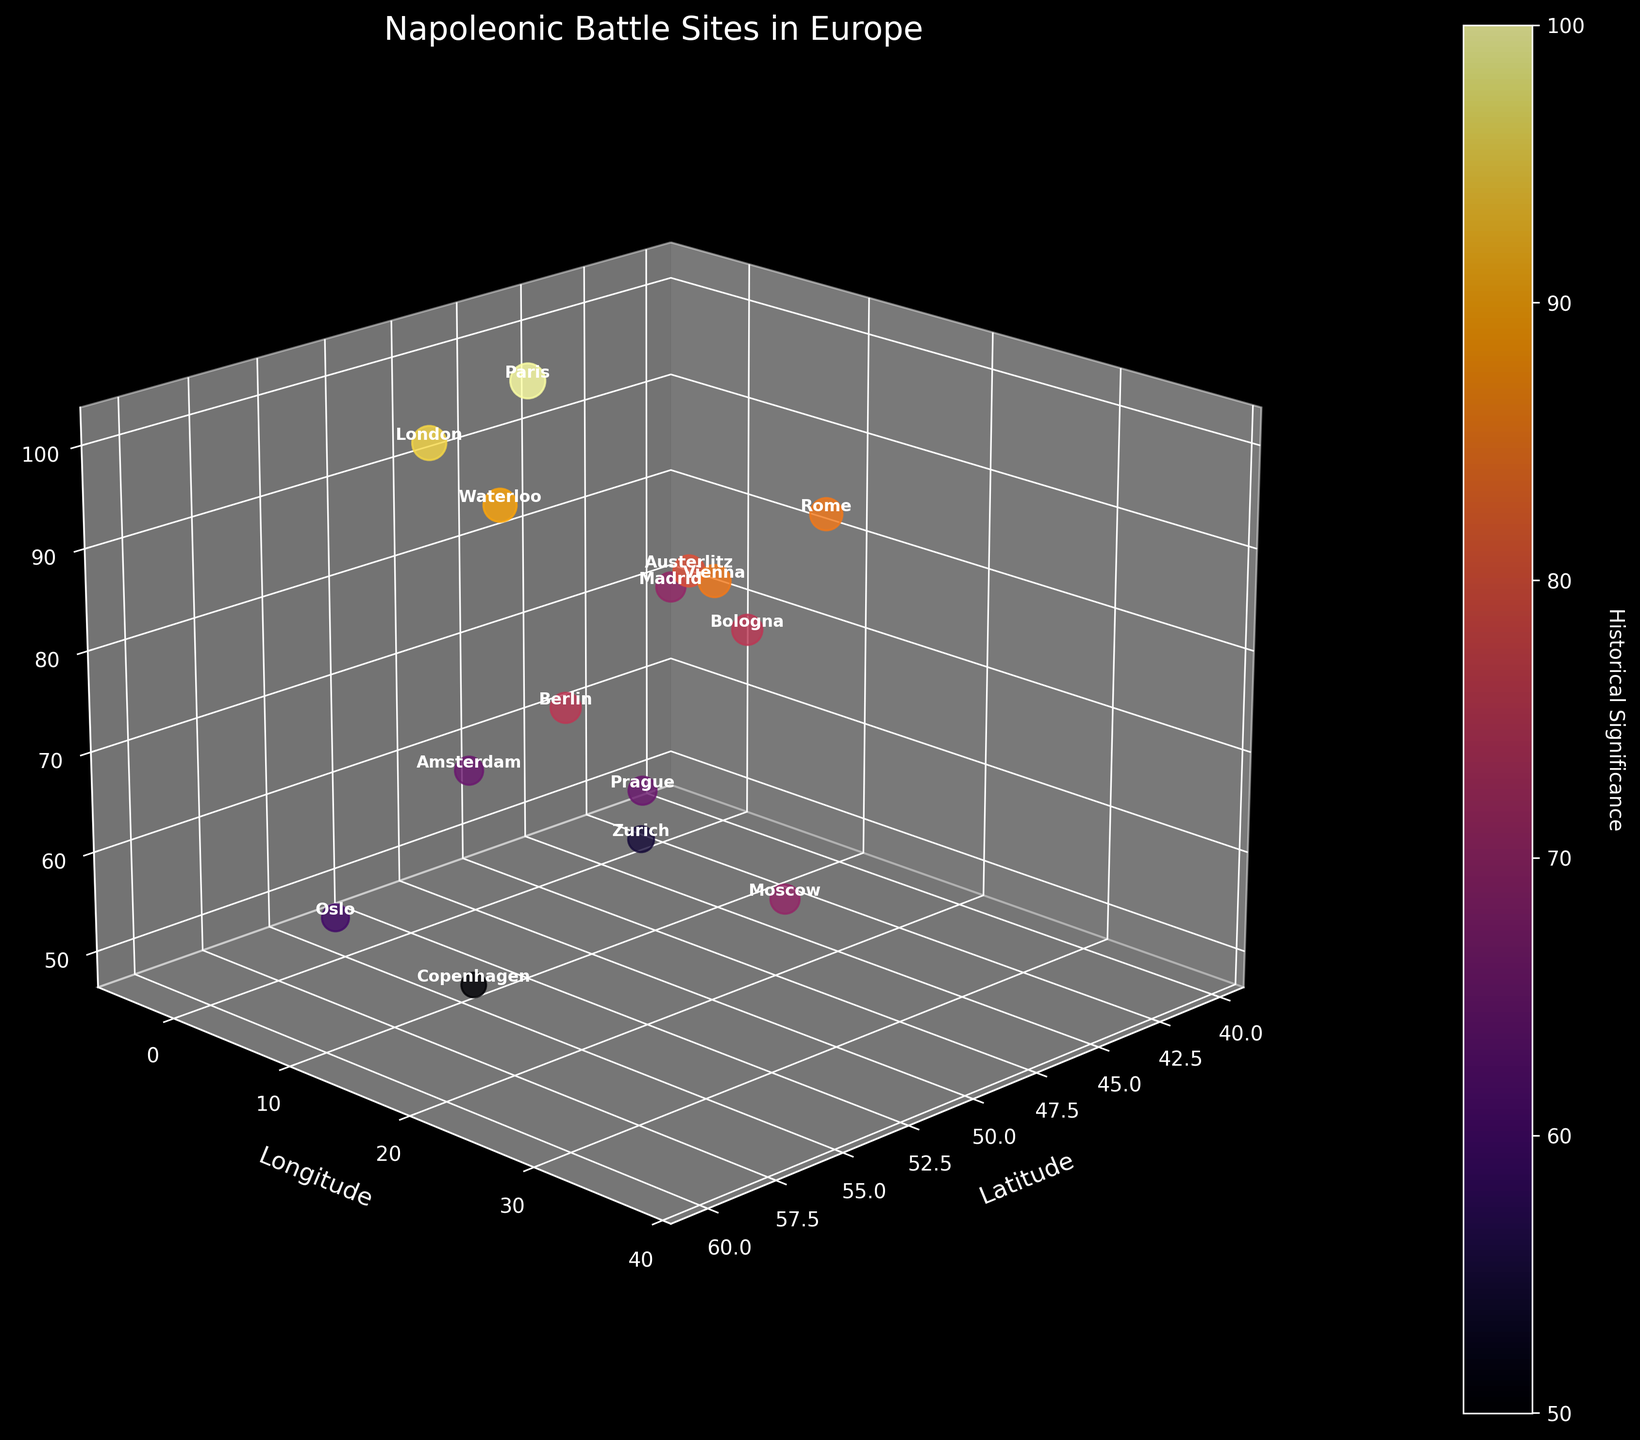Which city has the highest historical significance? The figure shows that Paris has the highest historical significance with a value of 100, as it is Napoleon's capital and center of power.
Answer: Paris Which two cities have historical significance values greater than 90, and what are they? By examining the z-axis values, Paris and London have historical significance values greater than 90. Paris at 100 and London at 95.
Answer: Paris and London What is the title of the 3D scatter plot? The title is displayed at the top of the plot and reads "Napoleonic Battle Sites in Europe."
Answer: Napoleonic Battle Sites in Europe How many data points are represented in the plot? By counting the number of text labels or data points, there are 15 data points in the 3D scatter plot.
Answer: 15 Which city occupies the lowest position in terms of historical significance? Using the z-axis, Copenhagen is shown to have the lowest historical significance value of 50.
Answer: Copenhagen What is the average historical significance across all cities? Finding the mean value of historical significance: (100 + 80 + 90 + 70 + 85 + 75 + 65 + 85 + 95 + 60 + 70 + 65 + 55 + 50 + 75)/15 = 74.
Answer: 74 Which city is positioned closest to Berlin on the plot in terms of latitude and longitude, and how do their historical significances compare? Comparing the coordinates, Prague (50.0755, 14.4378) is closest to Berlin (52.5200, 13.4050). Berlin has a historical significance of 75, while Prague has 65, making Berlin's significance higher by 10.
Answer: Prague; Berlin's significance is higher by 10 If you compare Waterloo and Moscow, which has a higher historical significance, and by how much? From the z-values, Waterloo has a significance of 90, whereas Moscow has 70, making Waterloo's significance higher by 20.
Answer: Waterloo by 20 Which data point corresponds to the historical significance value of 55, and what is its geographical location? Zurich has a historical significance of 55, located at coordinates 47.3769 latitude, 8.5417 longitude.
Answer: Zurich; 47.3769, 8.5417 What is the relationship between the cities of Rome and Vienna in terms of their historical significance? Both Rome and Vienna have an equal historical significance value of 85, making them equivalent in this metric.
Answer: Equal 